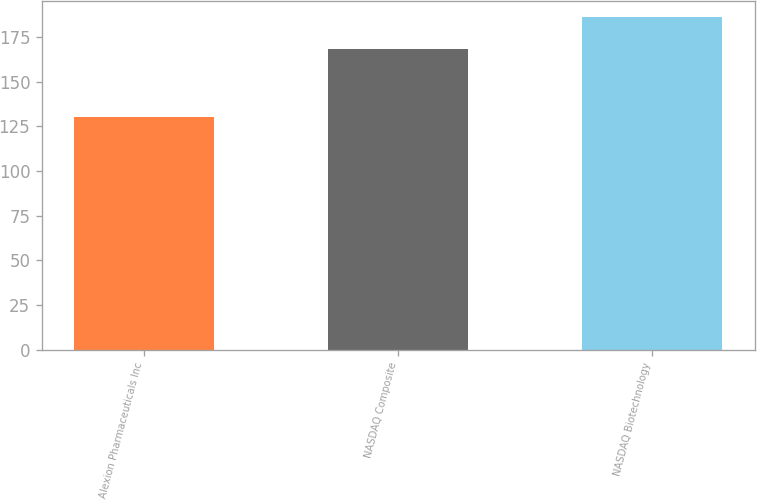Convert chart to OTSL. <chart><loc_0><loc_0><loc_500><loc_500><bar_chart><fcel>Alexion Pharmaceuticals Inc<fcel>NASDAQ Composite<fcel>NASDAQ Biotechnology<nl><fcel>130.56<fcel>168.24<fcel>186.1<nl></chart> 